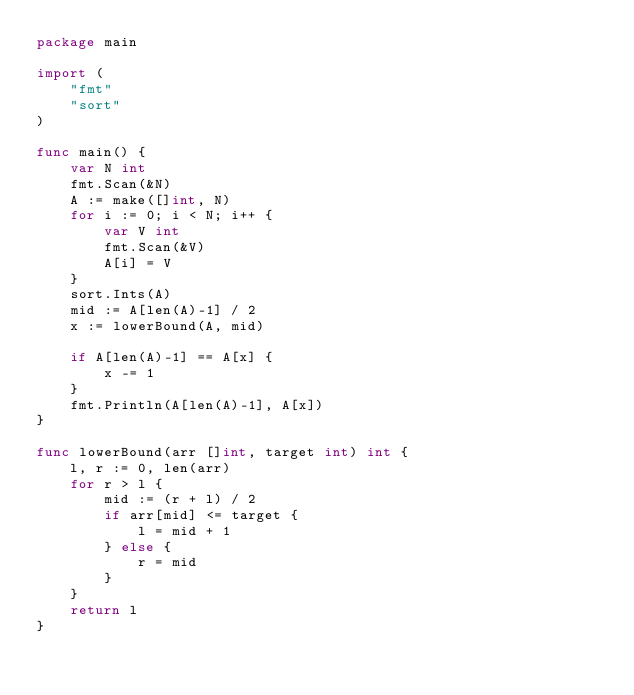Convert code to text. <code><loc_0><loc_0><loc_500><loc_500><_Go_>package main

import (
	"fmt"
	"sort"
)

func main() {
	var N int
	fmt.Scan(&N)
	A := make([]int, N)
	for i := 0; i < N; i++ {
		var V int
		fmt.Scan(&V)
		A[i] = V
	}
	sort.Ints(A)
	mid := A[len(A)-1] / 2
	x := lowerBound(A, mid)

	if A[len(A)-1] == A[x] {
		x -= 1
	}
	fmt.Println(A[len(A)-1], A[x])
}

func lowerBound(arr []int, target int) int {
	l, r := 0, len(arr)
	for r > l {
		mid := (r + l) / 2
		if arr[mid] <= target {
			l = mid + 1
		} else {
			r = mid
		}
	}
	return l
}
</code> 